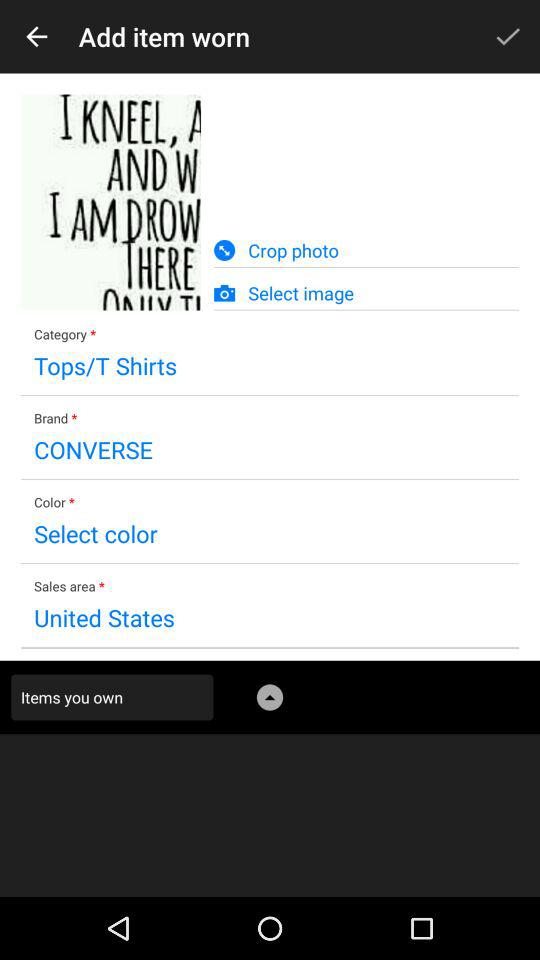What is the sales area? The sales area is the United States. 